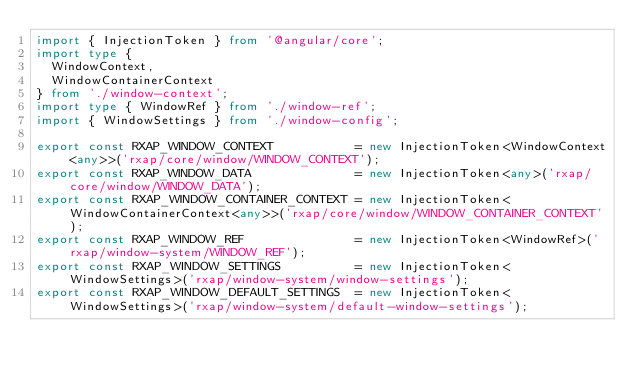<code> <loc_0><loc_0><loc_500><loc_500><_TypeScript_>import { InjectionToken } from '@angular/core';
import type {
  WindowContext,
  WindowContainerContext
} from './window-context';
import type { WindowRef } from './window-ref';
import { WindowSettings } from './window-config';

export const RXAP_WINDOW_CONTEXT           = new InjectionToken<WindowContext<any>>('rxap/core/window/WINDOW_CONTEXT');
export const RXAP_WINDOW_DATA              = new InjectionToken<any>('rxap/core/window/WINDOW_DATA');
export const RXAP_WINDOW_CONTAINER_CONTEXT = new InjectionToken<WindowContainerContext<any>>('rxap/core/window/WINDOW_CONTAINER_CONTEXT');
export const RXAP_WINDOW_REF               = new InjectionToken<WindowRef>('rxap/window-system/WINDOW_REF');
export const RXAP_WINDOW_SETTINGS          = new InjectionToken<WindowSettings>('rxap/window-system/window-settings');
export const RXAP_WINDOW_DEFAULT_SETTINGS  = new InjectionToken<WindowSettings>('rxap/window-system/default-window-settings');
</code> 